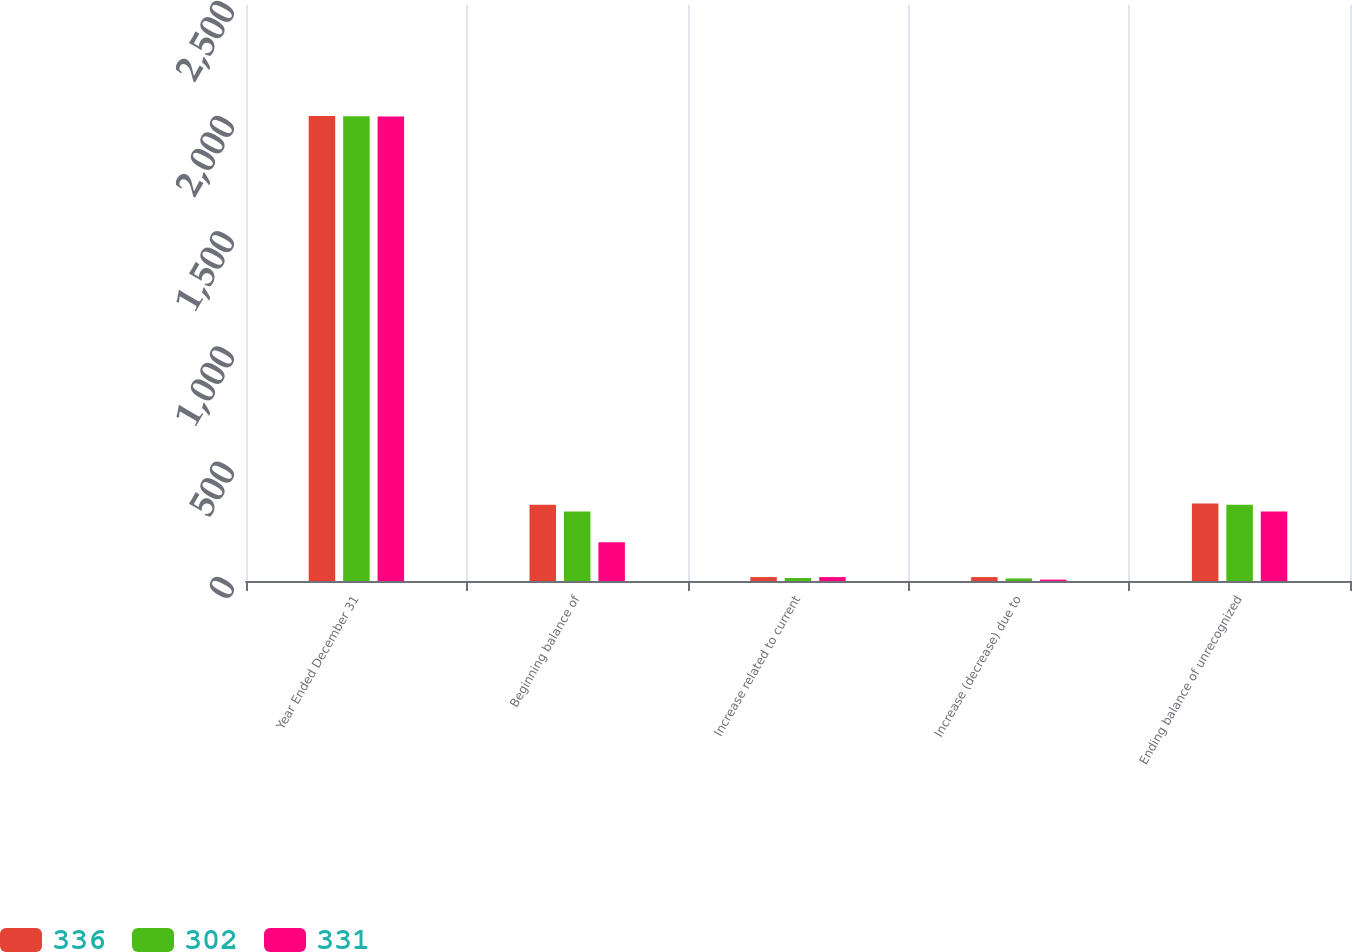<chart> <loc_0><loc_0><loc_500><loc_500><stacked_bar_chart><ecel><fcel>Year Ended December 31<fcel>Beginning balance of<fcel>Increase related to current<fcel>Increase (decrease) due to<fcel>Ending balance of unrecognized<nl><fcel>336<fcel>2018<fcel>331<fcel>17<fcel>17<fcel>336<nl><fcel>302<fcel>2017<fcel>302<fcel>13<fcel>11<fcel>331<nl><fcel>331<fcel>2016<fcel>168<fcel>17<fcel>6<fcel>302<nl></chart> 